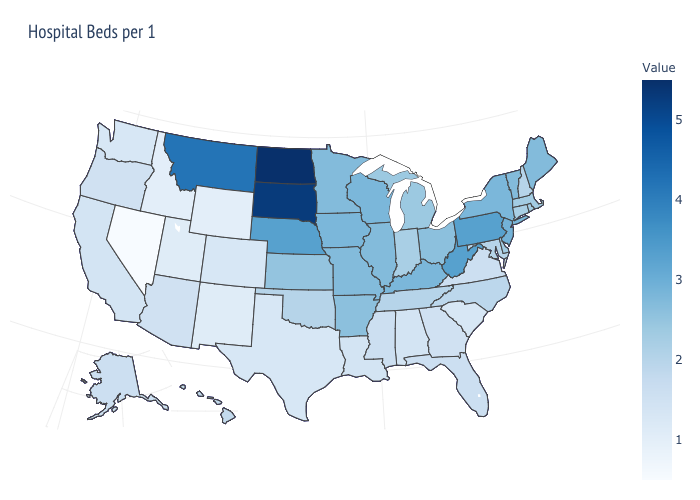Does Nevada have the lowest value in the USA?
Short answer required. Yes. Does North Dakota have the highest value in the USA?
Keep it brief. Yes. Does Pennsylvania have the highest value in the Northeast?
Give a very brief answer. Yes. Which states have the lowest value in the USA?
Write a very short answer. Nevada. Among the states that border South Carolina , does North Carolina have the highest value?
Write a very short answer. Yes. 